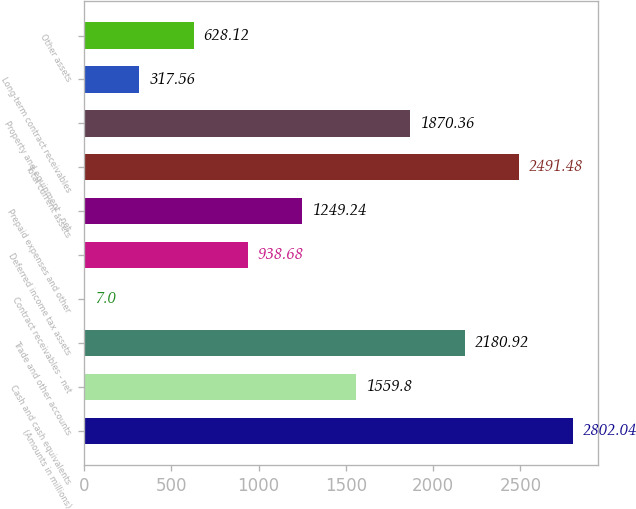Convert chart. <chart><loc_0><loc_0><loc_500><loc_500><bar_chart><fcel>(Amounts in millions)<fcel>Cash and cash equivalents<fcel>Trade and other accounts<fcel>Contract receivables - net<fcel>Deferred income tax assets<fcel>Prepaid expenses and other<fcel>Total current assets<fcel>Property and equipment - net<fcel>Long-term contract receivables<fcel>Other assets<nl><fcel>2802.04<fcel>1559.8<fcel>2180.92<fcel>7<fcel>938.68<fcel>1249.24<fcel>2491.48<fcel>1870.36<fcel>317.56<fcel>628.12<nl></chart> 